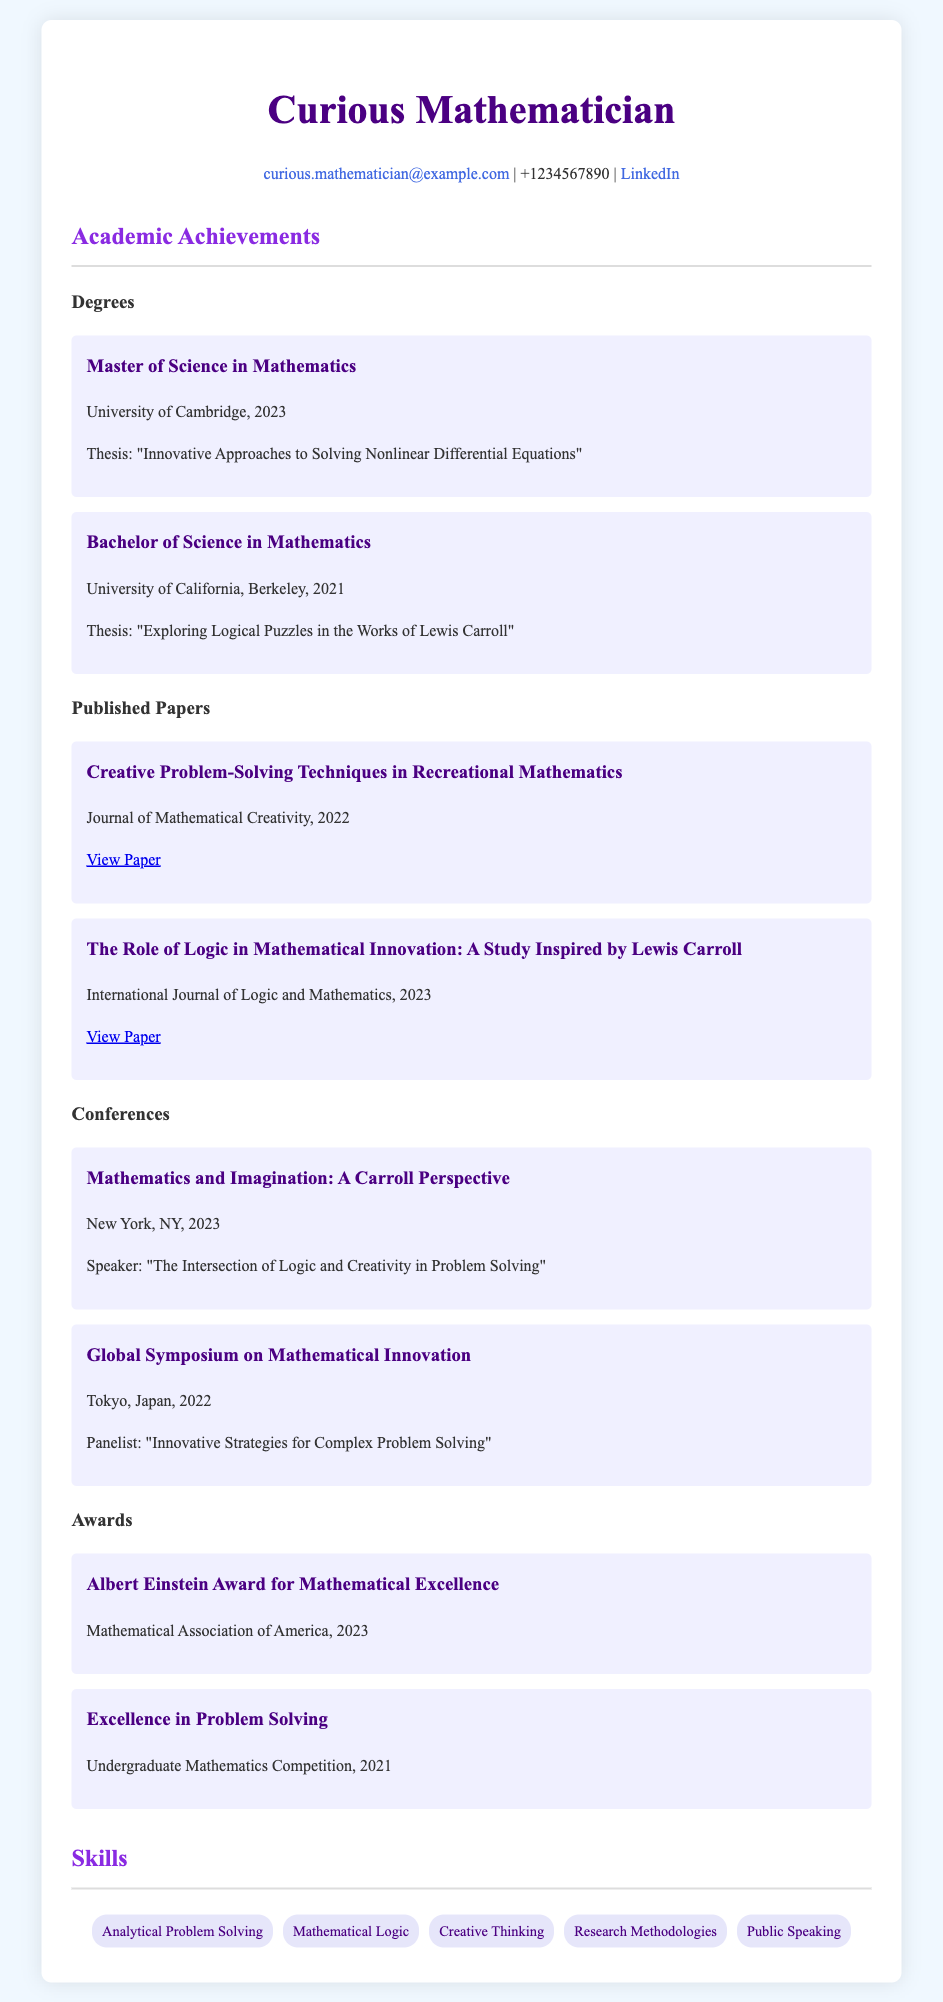What is the highest degree obtained? The highest degree listed is the Master of Science in Mathematics, which was completed at the University of Cambridge in 2023.
Answer: Master of Science in Mathematics What year was the thesis on nonlinear differential equations written? The thesis titled "Innovative Approaches to Solving Nonlinear Differential Equations" was completed in 2023 as part of the Master's degree.
Answer: 2023 How many published papers are mentioned in the document? The document lists two published papers under the Academic Achievements section.
Answer: Two What was the thesis topic for the Bachelor's degree? The thesis for the Bachelor's degree focused on exploring logical puzzles in the works of Lewis Carroll.
Answer: Exploring Logical Puzzles in the Works of Lewis Carroll Who received the Albert Einstein Award? The award was received by the Curious Mathematician from the Mathematical Association of America in 2023.
Answer: Curious Mathematician What conference did the mathematician present at in New York? The conference was titled "Mathematics and Imagination: A Carroll Perspective" and took place in 2023.
Answer: Mathematics and Imagination: A Carroll Perspective What skill related to speaking is mentioned in the document? Public Speaking is listed as one of the skills of the Curious Mathematician.
Answer: Public Speaking In what publication year did the paper on creative problem-solving techniques appear? The paper titled "Creative Problem-Solving Techniques in Recreational Mathematics" was published in 2022.
Answer: 2022 